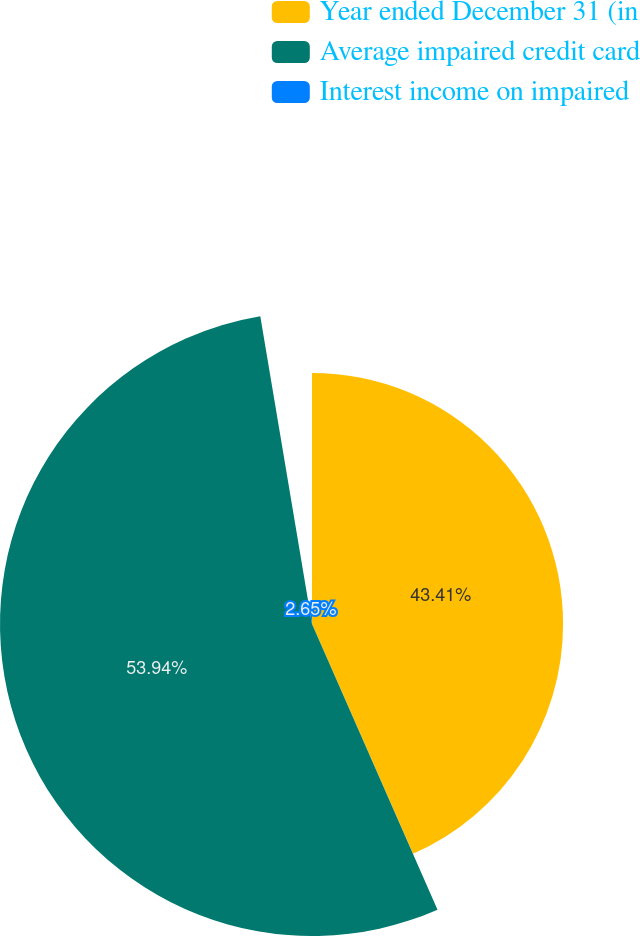Convert chart. <chart><loc_0><loc_0><loc_500><loc_500><pie_chart><fcel>Year ended December 31 (in<fcel>Average impaired credit card<fcel>Interest income on impaired<nl><fcel>43.41%<fcel>53.94%<fcel>2.65%<nl></chart> 